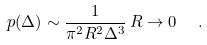<formula> <loc_0><loc_0><loc_500><loc_500>p ( \Delta ) \sim \frac { 1 } { \pi ^ { 2 } R ^ { 2 } \Delta ^ { 3 } } \, R \rightarrow 0 \ \ .</formula> 